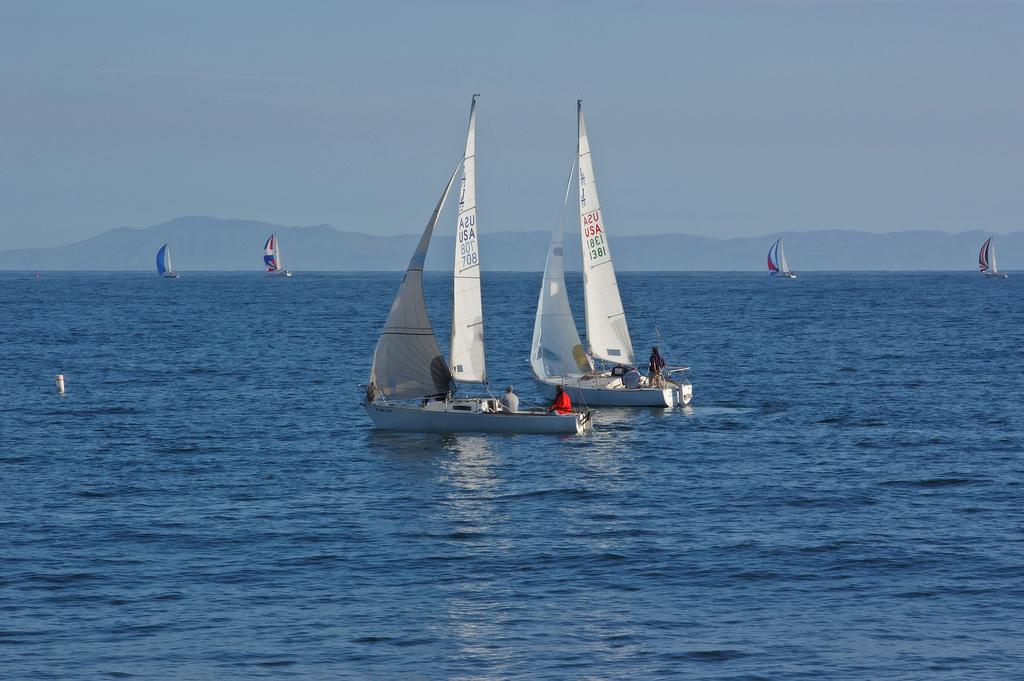What is the main subject of the image? The main subject of the image is ships. Where are the ships located? The ships are in the ocean. What can be seen in the background of the image? There are hills visible in the background of the image. What else is visible in the image besides the ships and hills? The sky is visible in the image. What type of oven can be seen in the image? There is no oven present in the image; it features ships in the ocean with hills and sky in the background. 